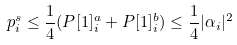Convert formula to latex. <formula><loc_0><loc_0><loc_500><loc_500>p ^ { s } _ { i } \leq \frac { 1 } { 4 } ( P [ 1 ] _ { i } ^ { a } + P [ 1 ] _ { i } ^ { b } ) \leq \frac { 1 } { 4 } | { \mathbf \alpha _ { i } } | ^ { 2 }</formula> 